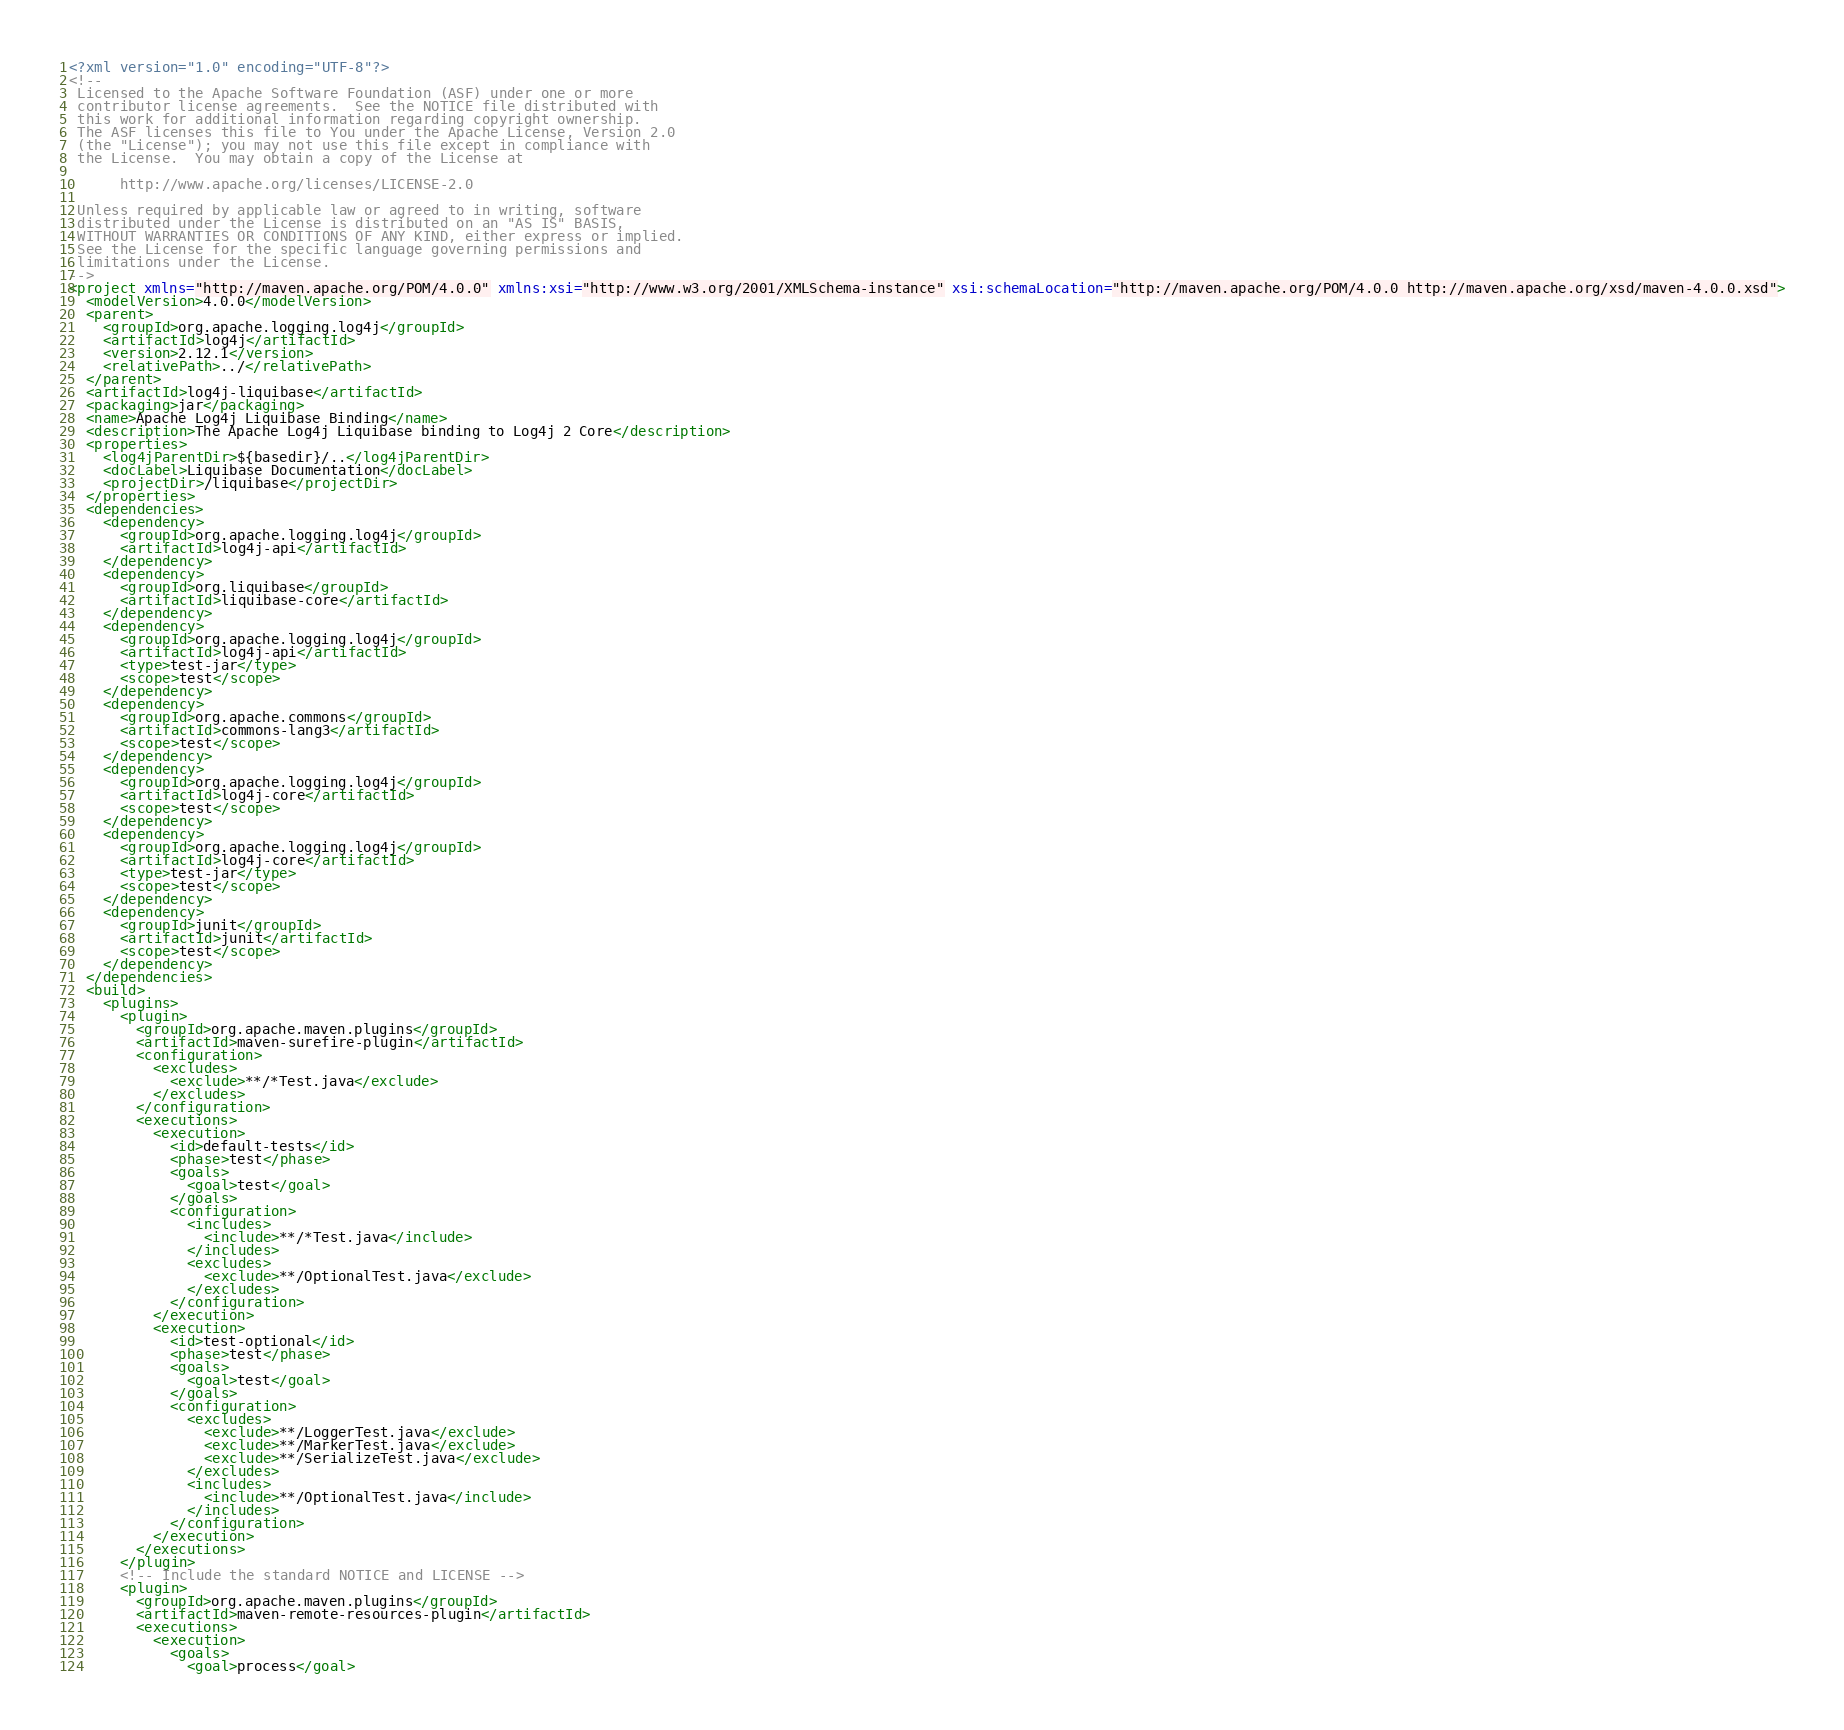Convert code to text. <code><loc_0><loc_0><loc_500><loc_500><_XML_><?xml version="1.0" encoding="UTF-8"?>
<!--
 Licensed to the Apache Software Foundation (ASF) under one or more
 contributor license agreements.  See the NOTICE file distributed with
 this work for additional information regarding copyright ownership.
 The ASF licenses this file to You under the Apache License, Version 2.0
 (the "License"); you may not use this file except in compliance with
 the License.  You may obtain a copy of the License at

      http://www.apache.org/licenses/LICENSE-2.0

 Unless required by applicable law or agreed to in writing, software
 distributed under the License is distributed on an "AS IS" BASIS,
 WITHOUT WARRANTIES OR CONDITIONS OF ANY KIND, either express or implied.
 See the License for the specific language governing permissions and
 limitations under the License.
-->
<project xmlns="http://maven.apache.org/POM/4.0.0" xmlns:xsi="http://www.w3.org/2001/XMLSchema-instance" xsi:schemaLocation="http://maven.apache.org/POM/4.0.0 http://maven.apache.org/xsd/maven-4.0.0.xsd">
  <modelVersion>4.0.0</modelVersion>
  <parent>
    <groupId>org.apache.logging.log4j</groupId>
    <artifactId>log4j</artifactId>
    <version>2.12.1</version>
    <relativePath>../</relativePath>
  </parent>
  <artifactId>log4j-liquibase</artifactId>
  <packaging>jar</packaging>
  <name>Apache Log4j Liquibase Binding</name>
  <description>The Apache Log4j Liquibase binding to Log4j 2 Core</description>
  <properties>
    <log4jParentDir>${basedir}/..</log4jParentDir>
    <docLabel>Liquibase Documentation</docLabel>
    <projectDir>/liquibase</projectDir>
  </properties>
  <dependencies>
    <dependency>
      <groupId>org.apache.logging.log4j</groupId>
      <artifactId>log4j-api</artifactId>
    </dependency>
    <dependency>
      <groupId>org.liquibase</groupId>
      <artifactId>liquibase-core</artifactId>
    </dependency>
    <dependency>
      <groupId>org.apache.logging.log4j</groupId>
      <artifactId>log4j-api</artifactId>
      <type>test-jar</type>
      <scope>test</scope>
    </dependency>
    <dependency>
      <groupId>org.apache.commons</groupId>
      <artifactId>commons-lang3</artifactId>
      <scope>test</scope>
    </dependency>
    <dependency>
      <groupId>org.apache.logging.log4j</groupId>
      <artifactId>log4j-core</artifactId>
      <scope>test</scope>
    </dependency>
    <dependency>
      <groupId>org.apache.logging.log4j</groupId>
      <artifactId>log4j-core</artifactId>
      <type>test-jar</type>
      <scope>test</scope>
    </dependency>
    <dependency>
      <groupId>junit</groupId>
      <artifactId>junit</artifactId>
      <scope>test</scope>
    </dependency>
  </dependencies>
  <build>
    <plugins>
      <plugin>
        <groupId>org.apache.maven.plugins</groupId>
        <artifactId>maven-surefire-plugin</artifactId>
        <configuration>
          <excludes>
            <exclude>**/*Test.java</exclude>
          </excludes>
        </configuration>
        <executions>
          <execution>
            <id>default-tests</id>
            <phase>test</phase>
            <goals>
              <goal>test</goal>
            </goals>
            <configuration>
              <includes>
                <include>**/*Test.java</include>
              </includes>
              <excludes>
                <exclude>**/OptionalTest.java</exclude>
              </excludes>
            </configuration>
          </execution>
          <execution>
            <id>test-optional</id>
            <phase>test</phase>
            <goals>
              <goal>test</goal>
            </goals>
            <configuration>
              <excludes>
                <exclude>**/LoggerTest.java</exclude>
                <exclude>**/MarkerTest.java</exclude>
                <exclude>**/SerializeTest.java</exclude>
              </excludes>
              <includes>
                <include>**/OptionalTest.java</include>
              </includes>
            </configuration>
          </execution>
        </executions>
      </plugin>
      <!-- Include the standard NOTICE and LICENSE -->
      <plugin>
        <groupId>org.apache.maven.plugins</groupId>
        <artifactId>maven-remote-resources-plugin</artifactId>
        <executions>
          <execution>
            <goals>
              <goal>process</goal></code> 